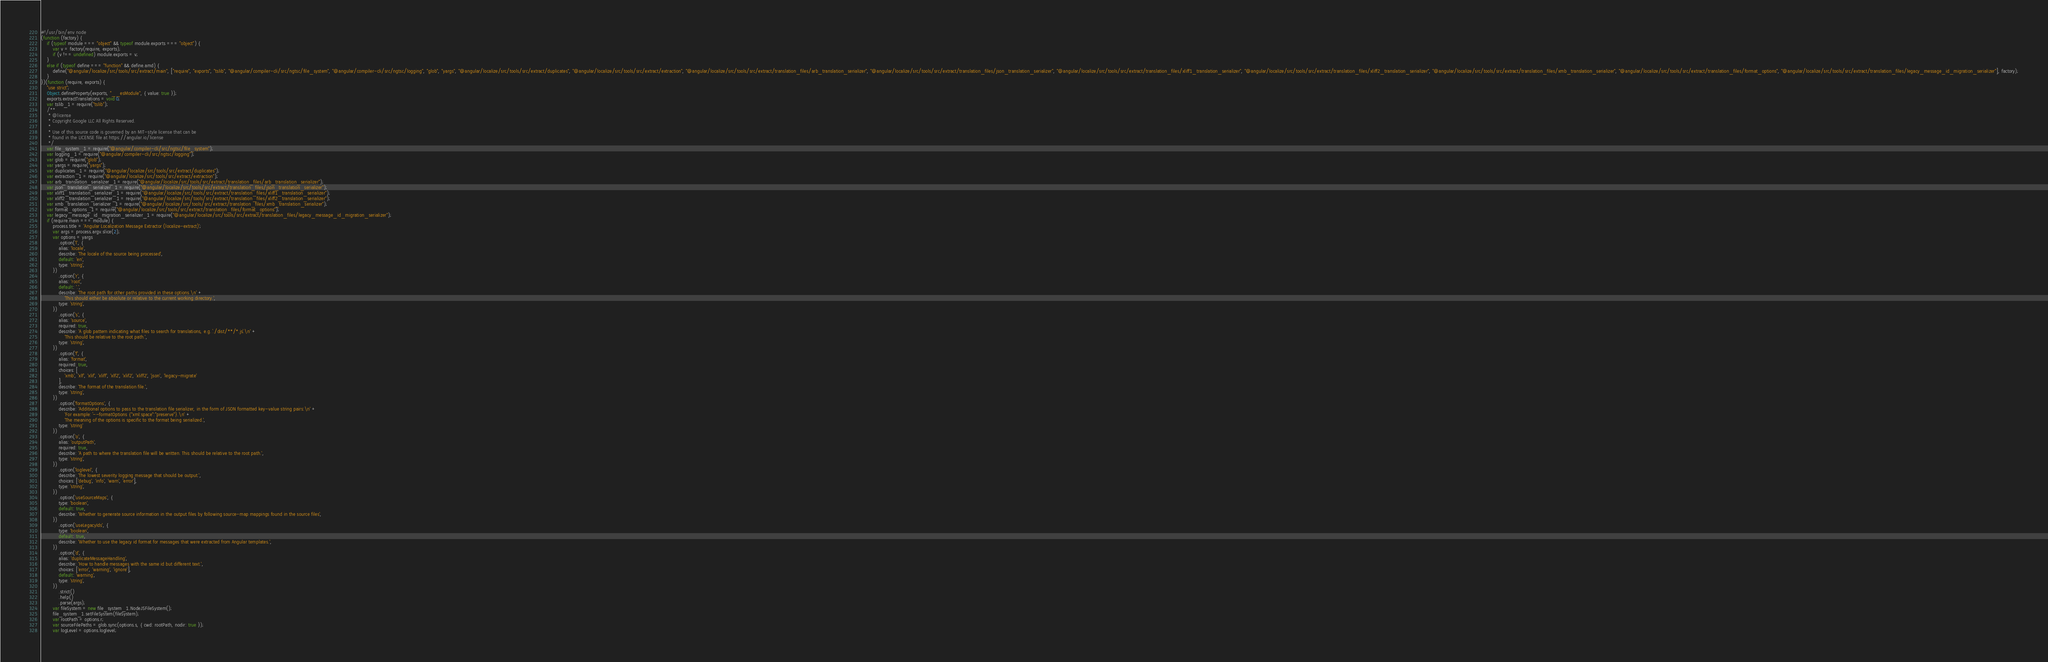Convert code to text. <code><loc_0><loc_0><loc_500><loc_500><_JavaScript_>#!/usr/bin/env node
(function (factory) {
    if (typeof module === "object" && typeof module.exports === "object") {
        var v = factory(require, exports);
        if (v !== undefined) module.exports = v;
    }
    else if (typeof define === "function" && define.amd) {
        define("@angular/localize/src/tools/src/extract/main", ["require", "exports", "tslib", "@angular/compiler-cli/src/ngtsc/file_system", "@angular/compiler-cli/src/ngtsc/logging", "glob", "yargs", "@angular/localize/src/tools/src/extract/duplicates", "@angular/localize/src/tools/src/extract/extraction", "@angular/localize/src/tools/src/extract/translation_files/arb_translation_serializer", "@angular/localize/src/tools/src/extract/translation_files/json_translation_serializer", "@angular/localize/src/tools/src/extract/translation_files/xliff1_translation_serializer", "@angular/localize/src/tools/src/extract/translation_files/xliff2_translation_serializer", "@angular/localize/src/tools/src/extract/translation_files/xmb_translation_serializer", "@angular/localize/src/tools/src/extract/translation_files/format_options", "@angular/localize/src/tools/src/extract/translation_files/legacy_message_id_migration_serializer"], factory);
    }
})(function (require, exports) {
    "use strict";
    Object.defineProperty(exports, "__esModule", { value: true });
    exports.extractTranslations = void 0;
    var tslib_1 = require("tslib");
    /**
     * @license
     * Copyright Google LLC All Rights Reserved.
     *
     * Use of this source code is governed by an MIT-style license that can be
     * found in the LICENSE file at https://angular.io/license
     */
    var file_system_1 = require("@angular/compiler-cli/src/ngtsc/file_system");
    var logging_1 = require("@angular/compiler-cli/src/ngtsc/logging");
    var glob = require("glob");
    var yargs = require("yargs");
    var duplicates_1 = require("@angular/localize/src/tools/src/extract/duplicates");
    var extraction_1 = require("@angular/localize/src/tools/src/extract/extraction");
    var arb_translation_serializer_1 = require("@angular/localize/src/tools/src/extract/translation_files/arb_translation_serializer");
    var json_translation_serializer_1 = require("@angular/localize/src/tools/src/extract/translation_files/json_translation_serializer");
    var xliff1_translation_serializer_1 = require("@angular/localize/src/tools/src/extract/translation_files/xliff1_translation_serializer");
    var xliff2_translation_serializer_1 = require("@angular/localize/src/tools/src/extract/translation_files/xliff2_translation_serializer");
    var xmb_translation_serializer_1 = require("@angular/localize/src/tools/src/extract/translation_files/xmb_translation_serializer");
    var format_options_1 = require("@angular/localize/src/tools/src/extract/translation_files/format_options");
    var legacy_message_id_migration_serializer_1 = require("@angular/localize/src/tools/src/extract/translation_files/legacy_message_id_migration_serializer");
    if (require.main === module) {
        process.title = 'Angular Localization Message Extractor (localize-extract)';
        var args = process.argv.slice(2);
        var options = yargs
            .option('l', {
            alias: 'locale',
            describe: 'The locale of the source being processed',
            default: 'en',
            type: 'string',
        })
            .option('r', {
            alias: 'root',
            default: '.',
            describe: 'The root path for other paths provided in these options.\n' +
                'This should either be absolute or relative to the current working directory.',
            type: 'string',
        })
            .option('s', {
            alias: 'source',
            required: true,
            describe: 'A glob pattern indicating what files to search for translations, e.g. `./dist/**/*.js`.\n' +
                'This should be relative to the root path.',
            type: 'string',
        })
            .option('f', {
            alias: 'format',
            required: true,
            choices: [
                'xmb', 'xlf', 'xlif', 'xliff', 'xlf2', 'xlif2', 'xliff2', 'json', 'legacy-migrate'
            ],
            describe: 'The format of the translation file.',
            type: 'string',
        })
            .option('formatOptions', {
            describe: 'Additional options to pass to the translation file serializer, in the form of JSON formatted key-value string pairs:\n' +
                'For example: `--formatOptions {"xml:space":"preserve"}.\n' +
                'The meaning of the options is specific to the format being serialized.',
            type: 'string'
        })
            .option('o', {
            alias: 'outputPath',
            required: true,
            describe: 'A path to where the translation file will be written. This should be relative to the root path.',
            type: 'string',
        })
            .option('loglevel', {
            describe: 'The lowest severity logging message that should be output.',
            choices: ['debug', 'info', 'warn', 'error'],
            type: 'string',
        })
            .option('useSourceMaps', {
            type: 'boolean',
            default: true,
            describe: 'Whether to generate source information in the output files by following source-map mappings found in the source files',
        })
            .option('useLegacyIds', {
            type: 'boolean',
            default: true,
            describe: 'Whether to use the legacy id format for messages that were extracted from Angular templates.',
        })
            .option('d', {
            alias: 'duplicateMessageHandling',
            describe: 'How to handle messages with the same id but different text.',
            choices: ['error', 'warning', 'ignore'],
            default: 'warning',
            type: 'string',
        })
            .strict()
            .help()
            .parse(args);
        var fileSystem = new file_system_1.NodeJSFileSystem();
        file_system_1.setFileSystem(fileSystem);
        var rootPath = options.r;
        var sourceFilePaths = glob.sync(options.s, { cwd: rootPath, nodir: true });
        var logLevel = options.loglevel;</code> 